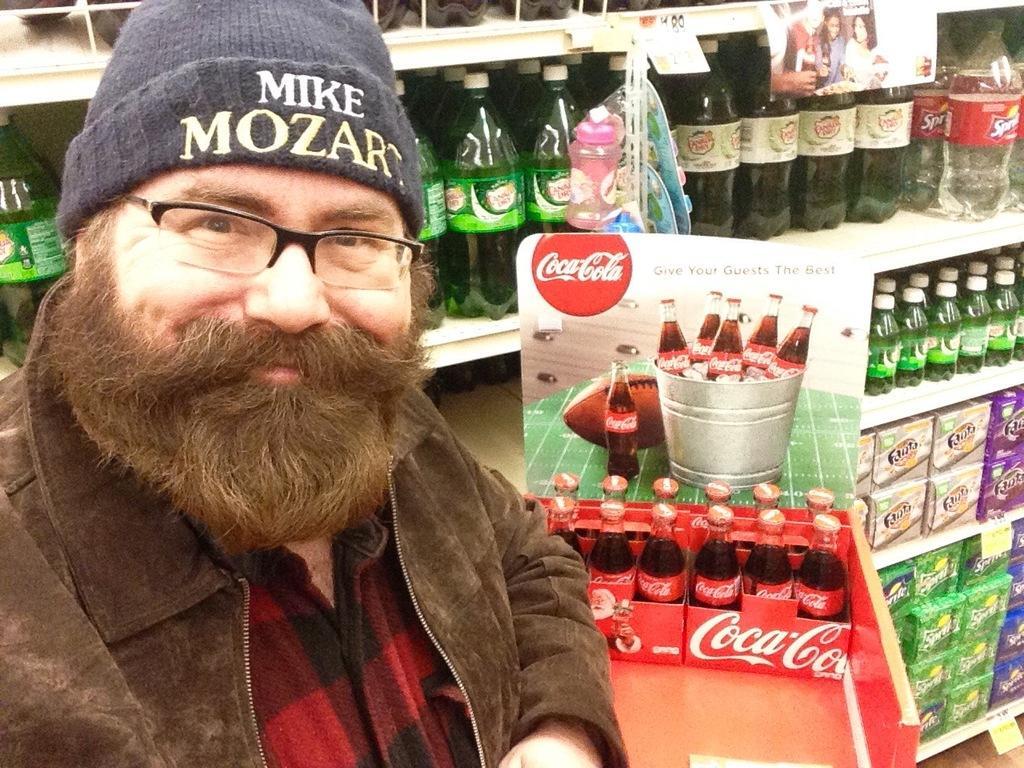How would you summarize this image in a sentence or two? In this image i can see a man smiling at the right there are few bottles the back ground there are few other bottles on a rack. 